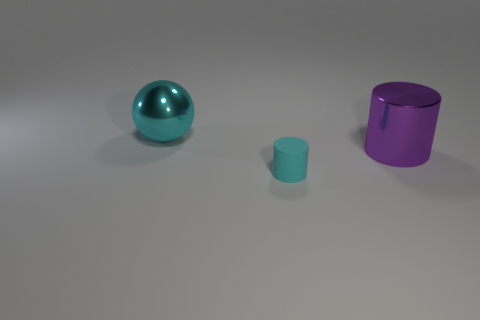Add 1 big red balls. How many objects exist? 4 Subtract all cylinders. How many objects are left? 1 Subtract all purple cylinders. How many cylinders are left? 1 Add 2 cyan cylinders. How many cyan cylinders exist? 3 Subtract 0 blue spheres. How many objects are left? 3 Subtract 2 cylinders. How many cylinders are left? 0 Subtract all blue cylinders. Subtract all purple cubes. How many cylinders are left? 2 Subtract all red spheres. How many blue cylinders are left? 0 Subtract all small cylinders. Subtract all metal spheres. How many objects are left? 1 Add 2 cyan spheres. How many cyan spheres are left? 3 